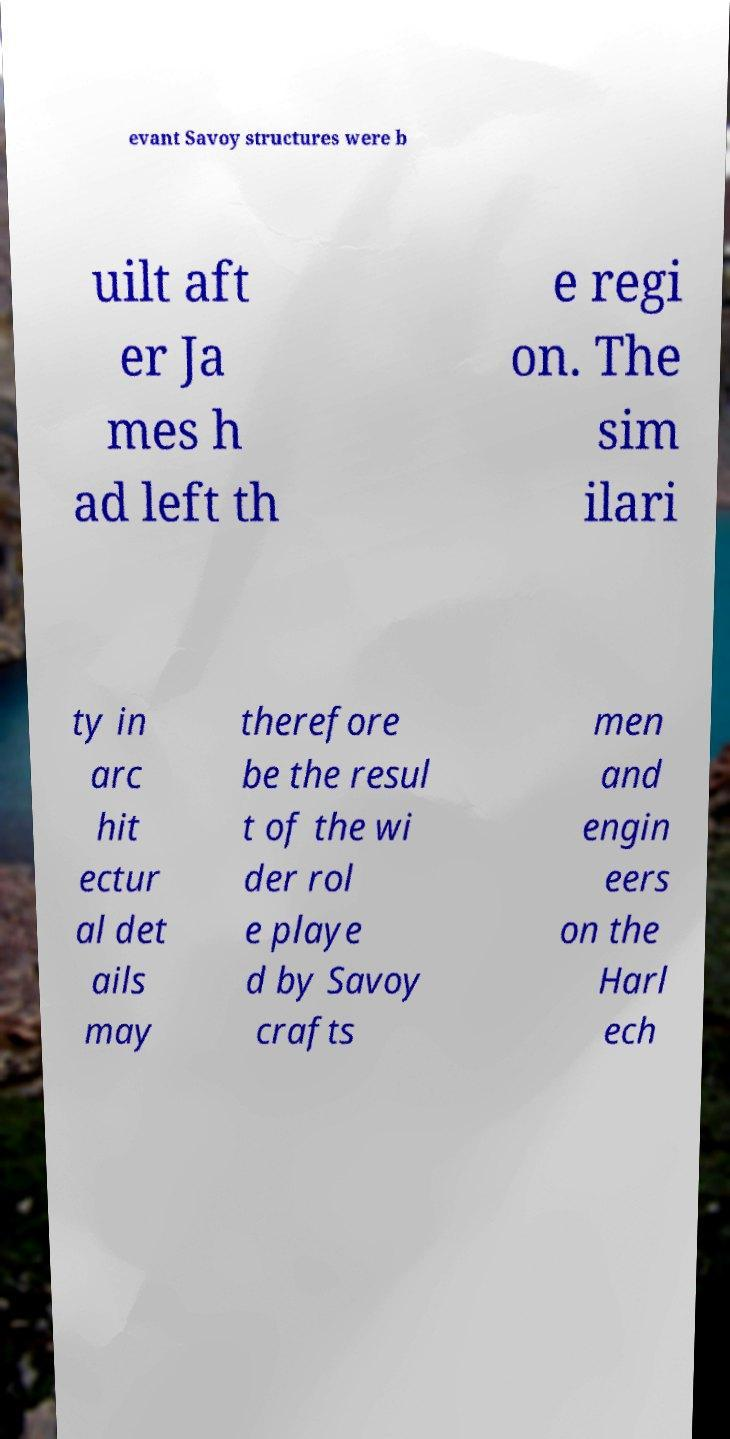What messages or text are displayed in this image? I need them in a readable, typed format. evant Savoy structures were b uilt aft er Ja mes h ad left th e regi on. The sim ilari ty in arc hit ectur al det ails may therefore be the resul t of the wi der rol e playe d by Savoy crafts men and engin eers on the Harl ech 